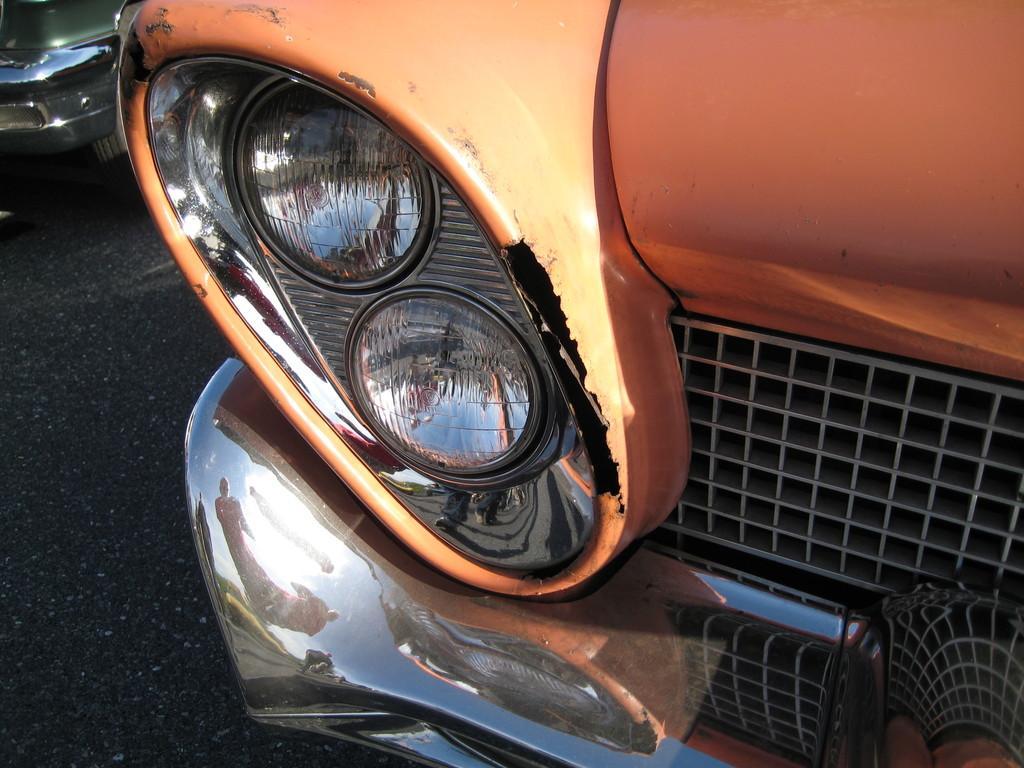Could you give a brief overview of what you see in this image? In this image I can see the front side part of a vehicle. There is a headlight, grill and a bumper. Also in the background there is another vehicle. 